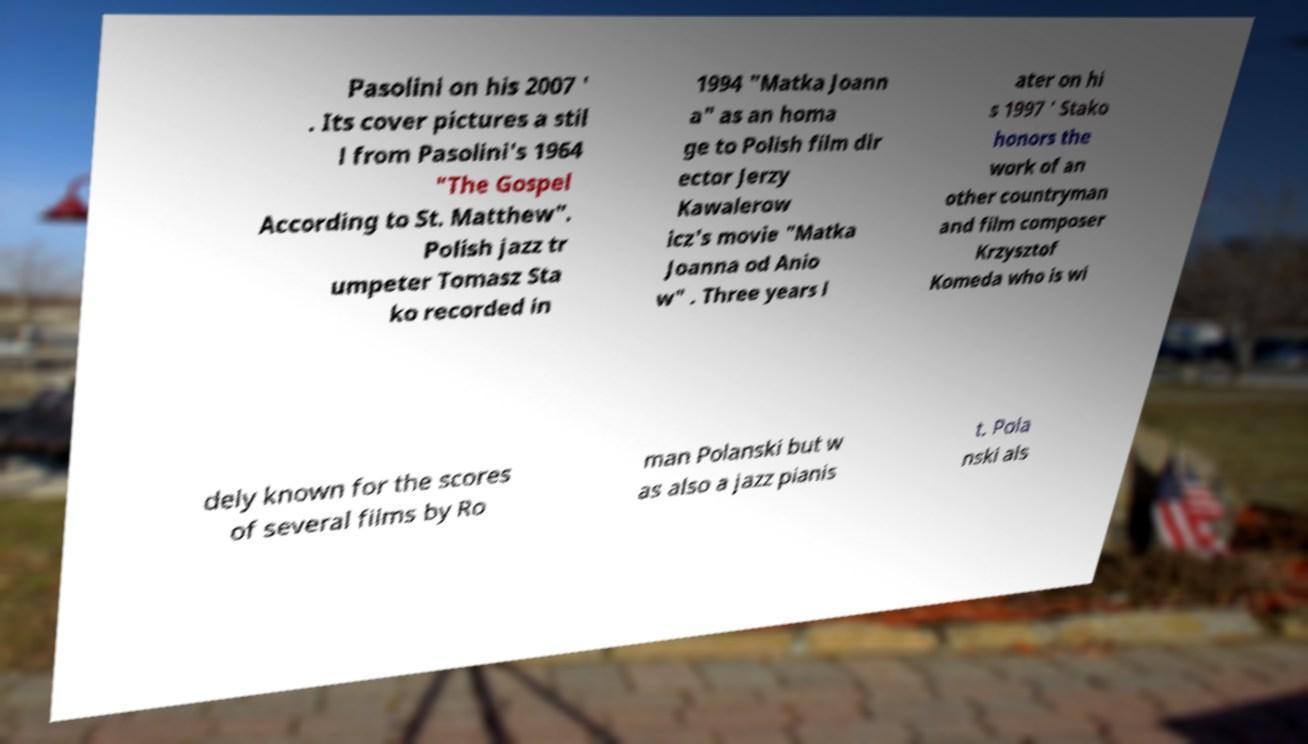Can you accurately transcribe the text from the provided image for me? Pasolini on his 2007 ' . Its cover pictures a stil l from Pasolini's 1964 "The Gospel According to St. Matthew". Polish jazz tr umpeter Tomasz Sta ko recorded in 1994 "Matka Joann a" as an homa ge to Polish film dir ector Jerzy Kawalerow icz's movie "Matka Joanna od Anio w" . Three years l ater on hi s 1997 ' Stako honors the work of an other countryman and film composer Krzysztof Komeda who is wi dely known for the scores of several films by Ro man Polanski but w as also a jazz pianis t. Pola nski als 